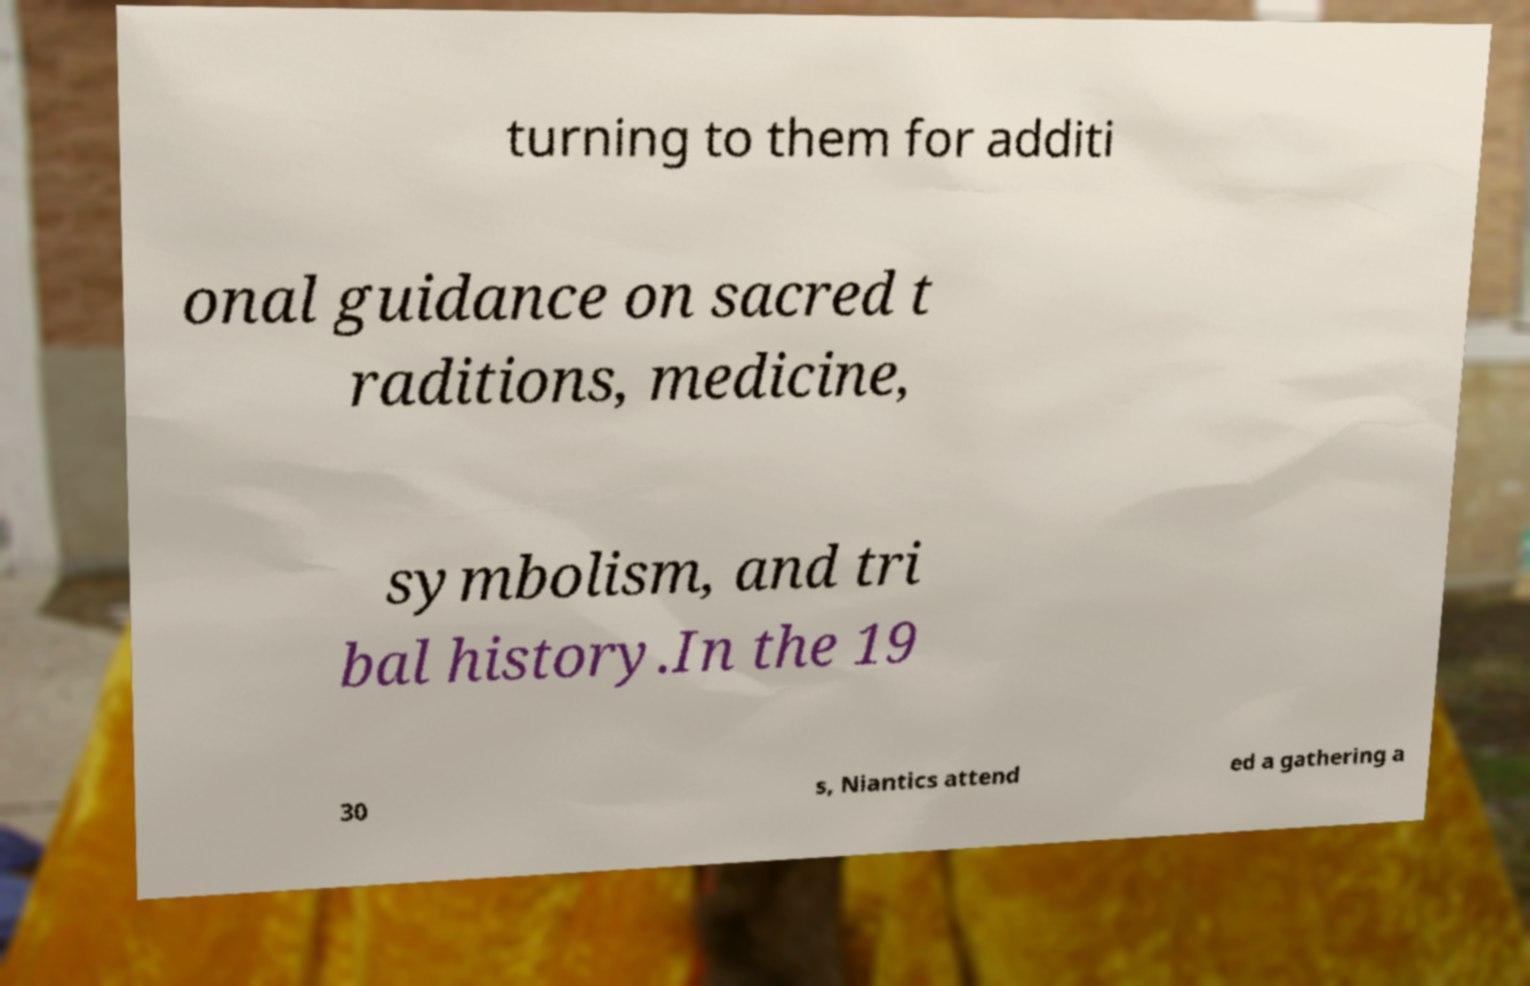Can you read and provide the text displayed in the image?This photo seems to have some interesting text. Can you extract and type it out for me? turning to them for additi onal guidance on sacred t raditions, medicine, symbolism, and tri bal history.In the 19 30 s, Niantics attend ed a gathering a 